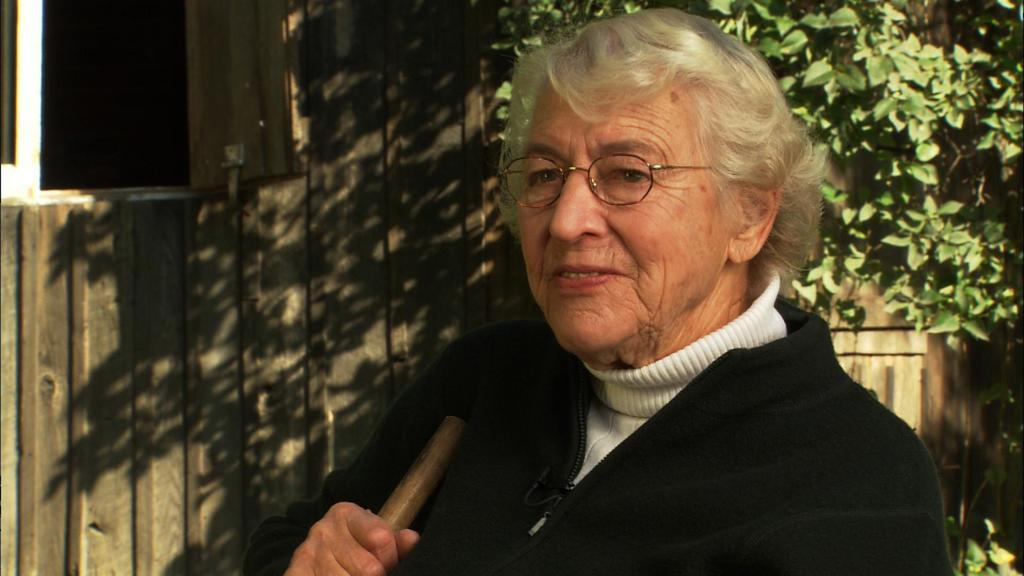What is the main subject in the foreground of the image? There is a person sitting in the foreground of the image. What is the person holding in the image? The person is holding a stick. What can be seen in the background of the image? There is a window, a wooden wall, and plants in the background of the image. What type of muscle can be seen flexing in the image? There is no muscle visible in the image; it features a person sitting and holding a stick. Can you describe the hill in the background of the image? There is no hill present in the image; it features a window, a wooden wall, and plants in the background. 